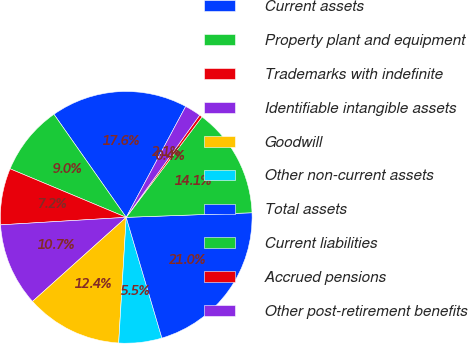Convert chart. <chart><loc_0><loc_0><loc_500><loc_500><pie_chart><fcel>Current assets<fcel>Property plant and equipment<fcel>Trademarks with indefinite<fcel>Identifiable intangible assets<fcel>Goodwill<fcel>Other non-current assets<fcel>Total assets<fcel>Current liabilities<fcel>Accrued pensions<fcel>Other post-retirement benefits<nl><fcel>17.57%<fcel>8.97%<fcel>7.25%<fcel>10.69%<fcel>12.41%<fcel>5.53%<fcel>21.01%<fcel>14.13%<fcel>0.37%<fcel>2.09%<nl></chart> 